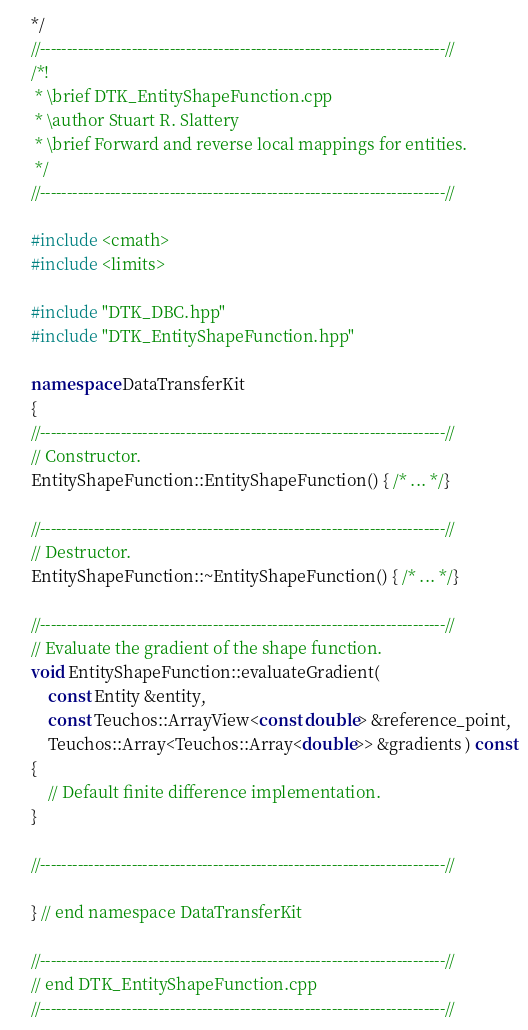Convert code to text. <code><loc_0><loc_0><loc_500><loc_500><_C++_>*/
//---------------------------------------------------------------------------//
/*!
 * \brief DTK_EntityShapeFunction.cpp
 * \author Stuart R. Slattery
 * \brief Forward and reverse local mappings for entities.
 */
//---------------------------------------------------------------------------//

#include <cmath>
#include <limits>

#include "DTK_DBC.hpp"
#include "DTK_EntityShapeFunction.hpp"

namespace DataTransferKit
{
//---------------------------------------------------------------------------//
// Constructor.
EntityShapeFunction::EntityShapeFunction() { /* ... */}

//---------------------------------------------------------------------------//
// Destructor.
EntityShapeFunction::~EntityShapeFunction() { /* ... */}

//---------------------------------------------------------------------------//
// Evaluate the gradient of the shape function.
void EntityShapeFunction::evaluateGradient(
    const Entity &entity,
    const Teuchos::ArrayView<const double> &reference_point,
    Teuchos::Array<Teuchos::Array<double>> &gradients ) const
{
    // Default finite difference implementation.
}

//---------------------------------------------------------------------------//

} // end namespace DataTransferKit

//---------------------------------------------------------------------------//
// end DTK_EntityShapeFunction.cpp
//---------------------------------------------------------------------------//
</code> 